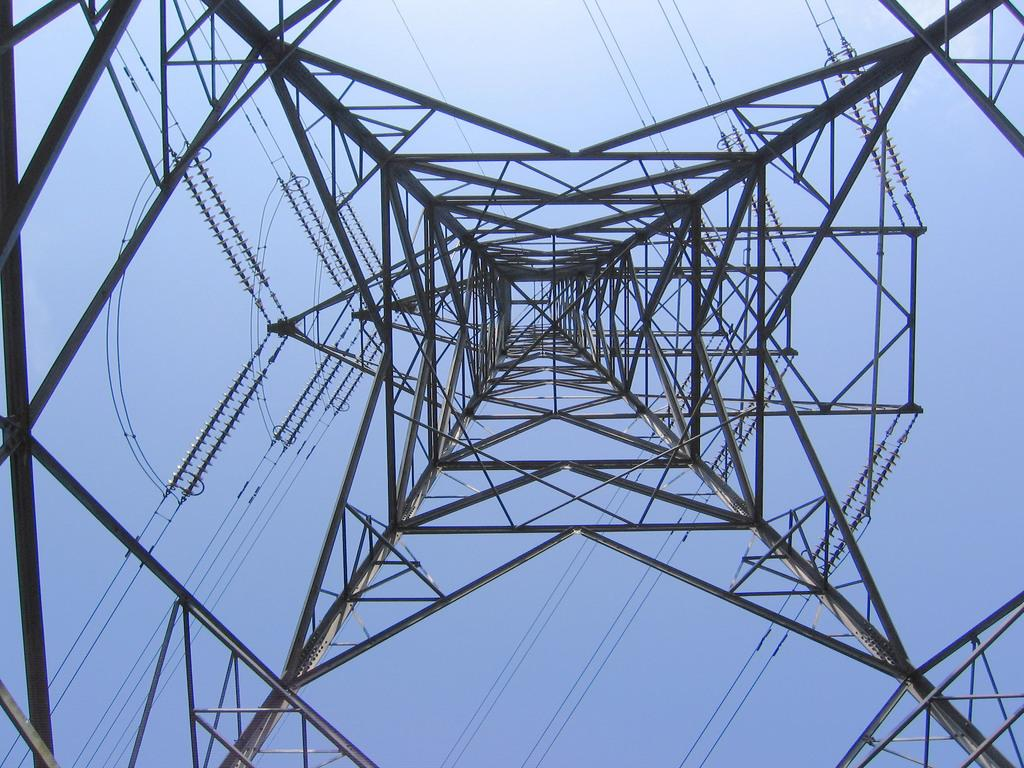What is the main structure in the image? There is a tower in the image. What can be seen in the background of the image? The sky is visible in the background of the image. What type of thread is being used to hold the meeting in the image? There is no meeting or thread present in the image; it only features a tower and the sky. 